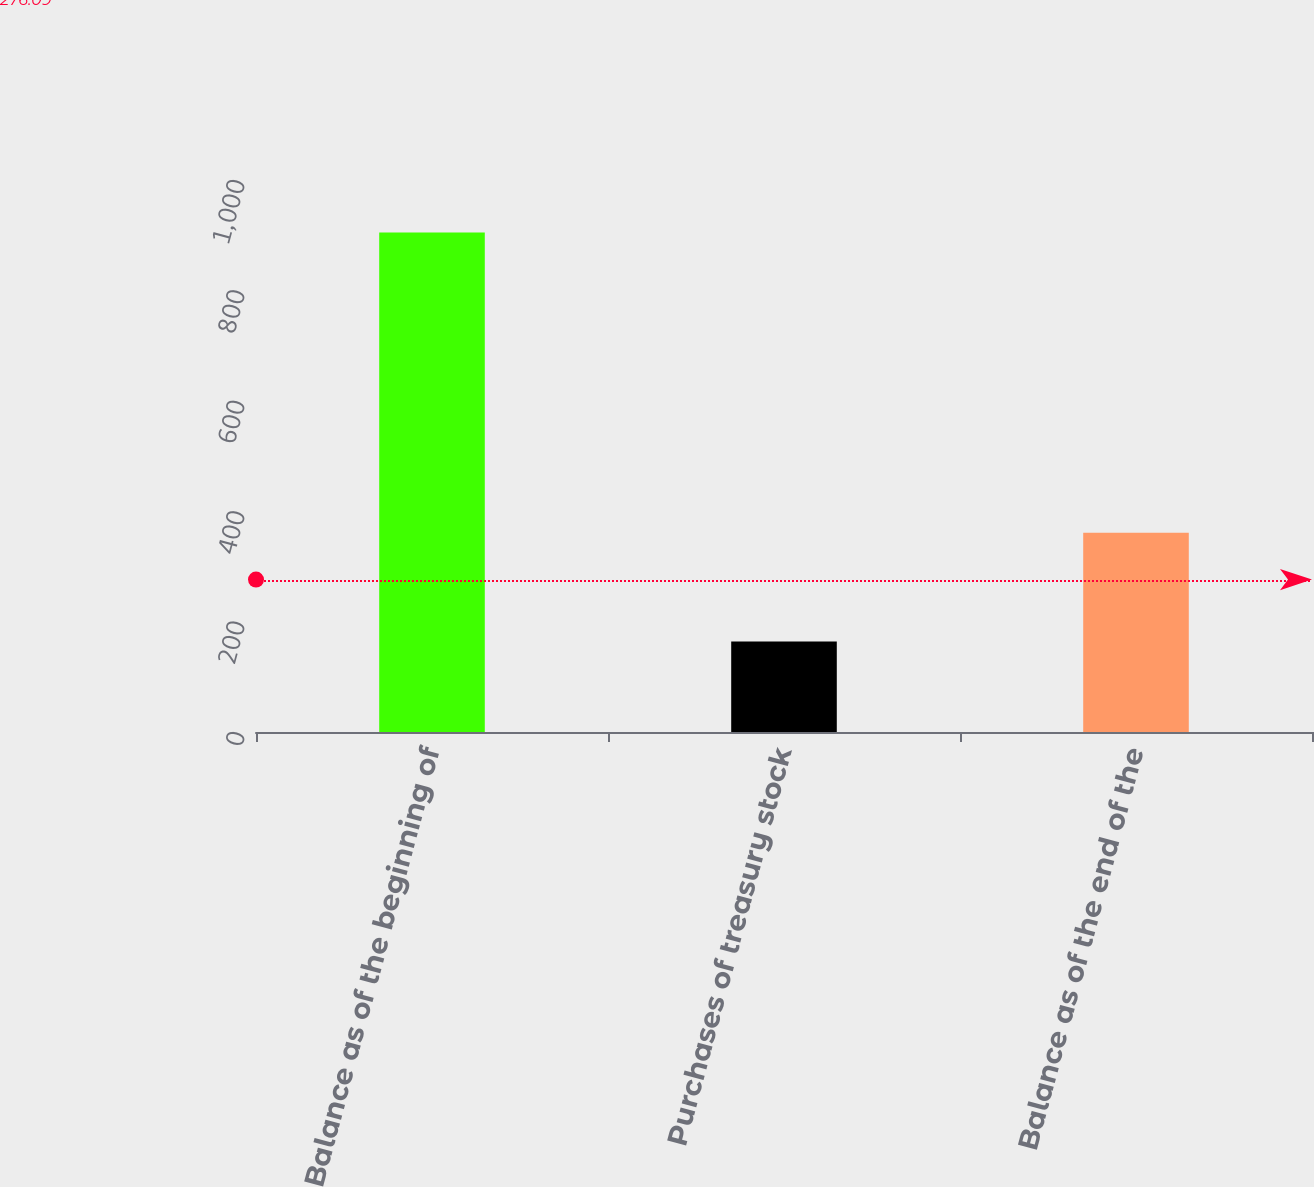Convert chart. <chart><loc_0><loc_0><loc_500><loc_500><bar_chart><fcel>Balance as of the beginning of<fcel>Purchases of treasury stock<fcel>Balance as of the end of the<nl><fcel>905<fcel>164<fcel>361<nl></chart> 